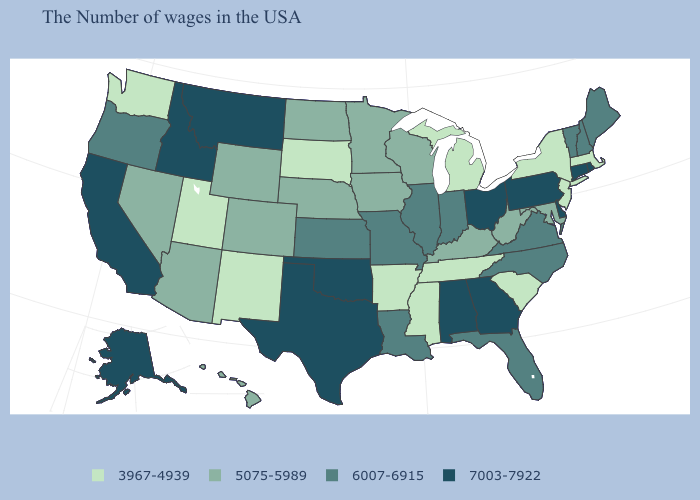What is the value of Kansas?
Answer briefly. 6007-6915. Name the states that have a value in the range 7003-7922?
Be succinct. Rhode Island, Connecticut, Delaware, Pennsylvania, Ohio, Georgia, Alabama, Oklahoma, Texas, Montana, Idaho, California, Alaska. What is the highest value in the USA?
Quick response, please. 7003-7922. Name the states that have a value in the range 5075-5989?
Concise answer only. Maryland, West Virginia, Kentucky, Wisconsin, Minnesota, Iowa, Nebraska, North Dakota, Wyoming, Colorado, Arizona, Nevada, Hawaii. What is the value of Colorado?
Short answer required. 5075-5989. Name the states that have a value in the range 5075-5989?
Write a very short answer. Maryland, West Virginia, Kentucky, Wisconsin, Minnesota, Iowa, Nebraska, North Dakota, Wyoming, Colorado, Arizona, Nevada, Hawaii. What is the value of Massachusetts?
Answer briefly. 3967-4939. Name the states that have a value in the range 5075-5989?
Keep it brief. Maryland, West Virginia, Kentucky, Wisconsin, Minnesota, Iowa, Nebraska, North Dakota, Wyoming, Colorado, Arizona, Nevada, Hawaii. Which states have the lowest value in the USA?
Write a very short answer. Massachusetts, New York, New Jersey, South Carolina, Michigan, Tennessee, Mississippi, Arkansas, South Dakota, New Mexico, Utah, Washington. What is the value of Delaware?
Quick response, please. 7003-7922. Which states hav the highest value in the Northeast?
Quick response, please. Rhode Island, Connecticut, Pennsylvania. What is the value of Arizona?
Keep it brief. 5075-5989. What is the value of Maine?
Write a very short answer. 6007-6915. Name the states that have a value in the range 7003-7922?
Give a very brief answer. Rhode Island, Connecticut, Delaware, Pennsylvania, Ohio, Georgia, Alabama, Oklahoma, Texas, Montana, Idaho, California, Alaska. What is the highest value in the USA?
Write a very short answer. 7003-7922. 